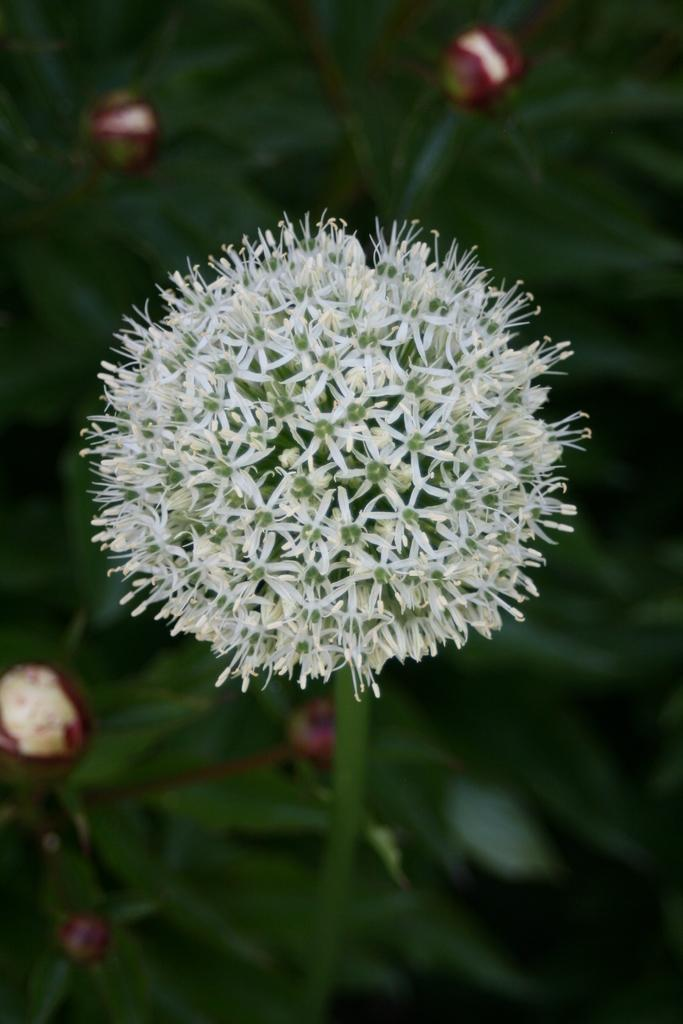What is the main subject of the image? There is a flower in the image. Can you describe the background of the image? The background of the image is blurred. How many cows are present in the image? There are no cows present in the image; it features a flower with a blurred background. What type of ornament is hanging from the flower in the image? There is no ornament hanging from the flower in the image; it is a single flower with a blurred background. 